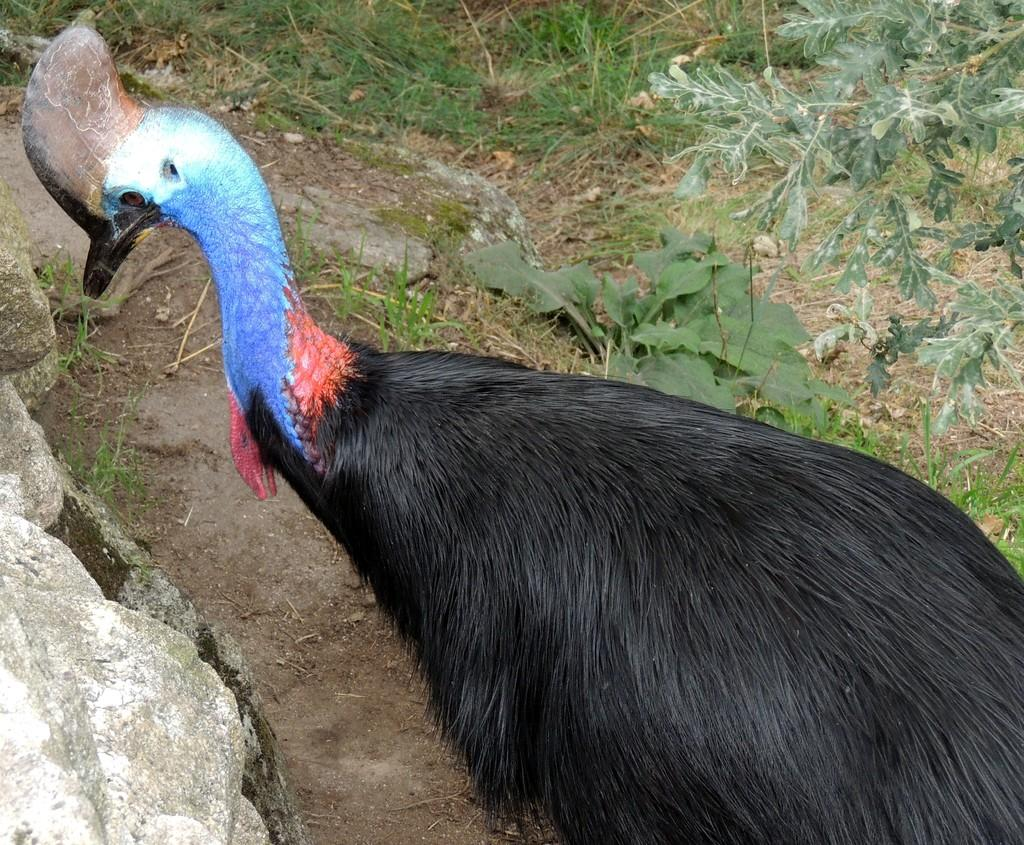What type of animal can be seen on the surface in the image? There is a bird on the surface in the image. What celestial bodies are visible on the right side of the image? There are planets visible on the right side of the image. What geological feature can be seen on the left side of the image? There is a rock on the left side of the image. How many chairs are visible in the image? There are no chairs present in the image. What type of shoe is the bird wearing in the image? Birds do not wear shoes, and there is no shoe present in the image. 